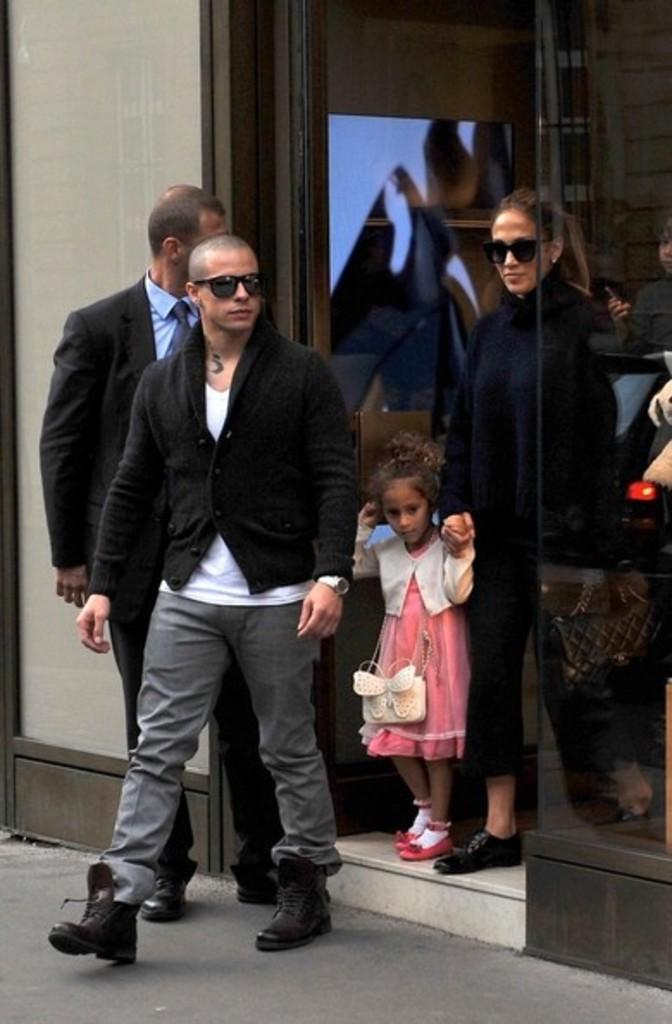Can you describe this image briefly? In the picture we can see a man walking out from the glass door and behind him we can see a woman and a girl child are also walking. 